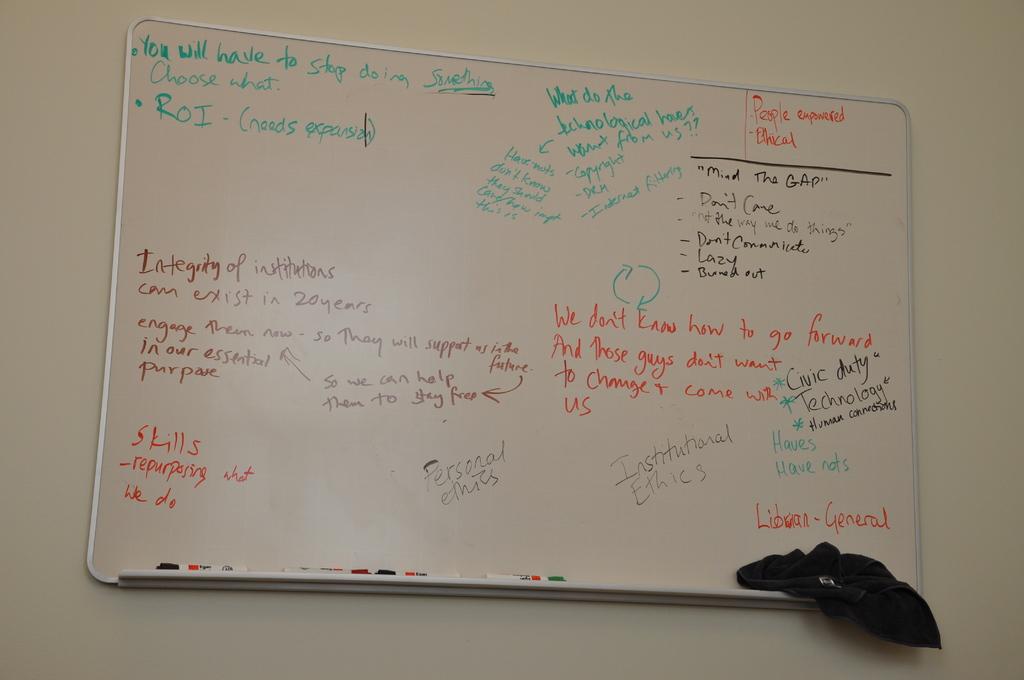What types of ethics are mentioned at the bottom of the board?
Keep it short and to the point. Personal. What is the 3 letter word in green top left?
Your answer should be very brief. Roi. 